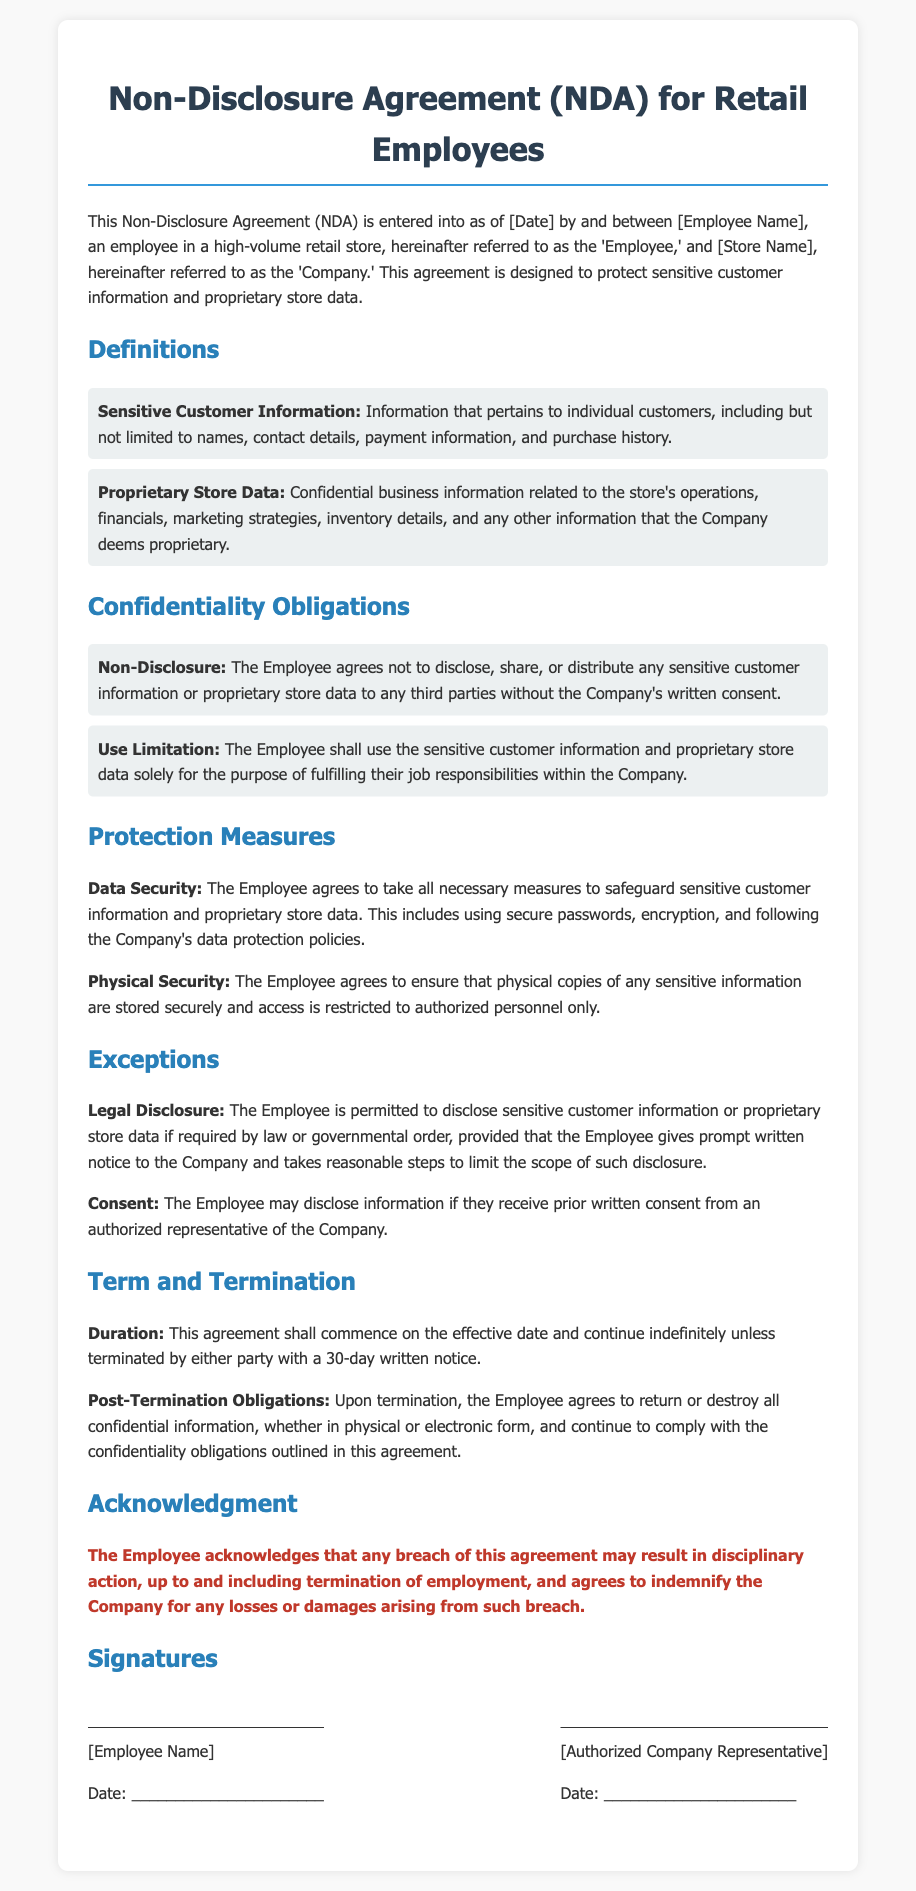What is the date of the agreement? The date of the agreement should be specified in the place marked [Date] within the document, which is currently a placeholder.
Answer: [Date] Who is referred to as the 'Employee'? The 'Employee' is identified as [Employee Name], indicating their identity is to be filled in.
Answer: [Employee Name] What type of information does "Sensitive Customer Information" include? The document states that it includes names, contact details, payment information, and purchase history.
Answer: Names, contact details, payment information, and purchase history What is the duration of the NDA agreement? The duration is stated as indefinite unless terminated by either party with a 30-day written notice.
Answer: Indefinite What must the Employee do with confidential information upon termination? The Employee is obligated to return or destroy all confidential information after termination.
Answer: Return or destroy all confidential information Which section addresses legal disclosure permissions? The section titled "Exceptions" addresses the situations where legal disclosure is permitted.
Answer: Exceptions What security measures are specified for safeguarding sensitive information? The Employee must use secure passwords, encryption, and follow the Company’s data protection policies.
Answer: Secure passwords, encryption, and data protection policies Who must provide written consent for sharing sensitive information? An authorized representative of the Company must provide prior written consent for the disclosure.
Answer: Authorized representative of the Company What kind of action may occur if there's a breach of the NDA? The document warns that disciplinary action may result, up to and including termination of employment.
Answer: Disciplinary action, including termination of employment 